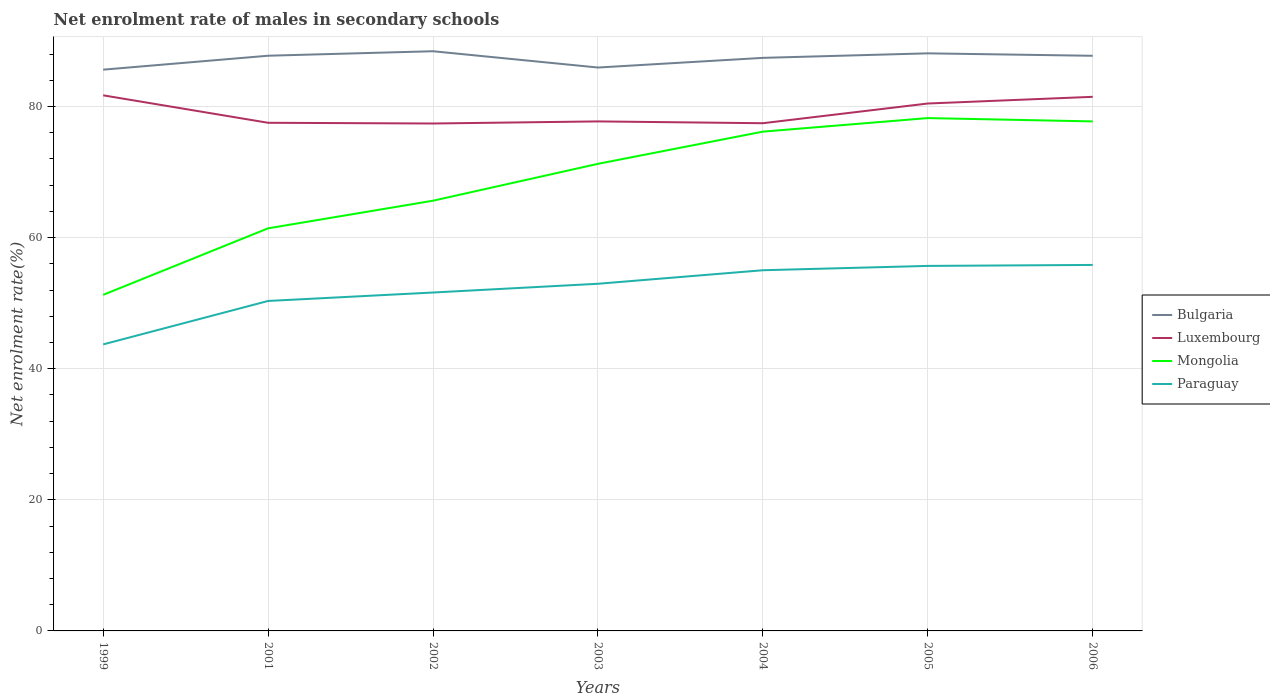Does the line corresponding to Bulgaria intersect with the line corresponding to Luxembourg?
Make the answer very short. No. Is the number of lines equal to the number of legend labels?
Give a very brief answer. Yes. Across all years, what is the maximum net enrolment rate of males in secondary schools in Bulgaria?
Provide a succinct answer. 85.63. What is the total net enrolment rate of males in secondary schools in Luxembourg in the graph?
Provide a short and direct response. -2.94. What is the difference between the highest and the second highest net enrolment rate of males in secondary schools in Luxembourg?
Your answer should be very brief. 4.3. What is the difference between the highest and the lowest net enrolment rate of males in secondary schools in Mongolia?
Your response must be concise. 4. How many lines are there?
Your answer should be very brief. 4. What is the difference between two consecutive major ticks on the Y-axis?
Provide a short and direct response. 20. Are the values on the major ticks of Y-axis written in scientific E-notation?
Ensure brevity in your answer.  No. Where does the legend appear in the graph?
Offer a very short reply. Center right. How many legend labels are there?
Offer a terse response. 4. How are the legend labels stacked?
Offer a terse response. Vertical. What is the title of the graph?
Provide a short and direct response. Net enrolment rate of males in secondary schools. What is the label or title of the X-axis?
Your response must be concise. Years. What is the label or title of the Y-axis?
Your answer should be compact. Net enrolment rate(%). What is the Net enrolment rate(%) of Bulgaria in 1999?
Keep it short and to the point. 85.63. What is the Net enrolment rate(%) of Luxembourg in 1999?
Offer a very short reply. 81.71. What is the Net enrolment rate(%) of Mongolia in 1999?
Your answer should be compact. 51.28. What is the Net enrolment rate(%) of Paraguay in 1999?
Your answer should be compact. 43.71. What is the Net enrolment rate(%) in Bulgaria in 2001?
Make the answer very short. 87.76. What is the Net enrolment rate(%) of Luxembourg in 2001?
Your answer should be compact. 77.53. What is the Net enrolment rate(%) of Mongolia in 2001?
Make the answer very short. 61.42. What is the Net enrolment rate(%) of Paraguay in 2001?
Your response must be concise. 50.34. What is the Net enrolment rate(%) in Bulgaria in 2002?
Your answer should be compact. 88.44. What is the Net enrolment rate(%) of Luxembourg in 2002?
Your response must be concise. 77.42. What is the Net enrolment rate(%) in Mongolia in 2002?
Keep it short and to the point. 65.64. What is the Net enrolment rate(%) in Paraguay in 2002?
Your answer should be very brief. 51.63. What is the Net enrolment rate(%) in Bulgaria in 2003?
Offer a very short reply. 85.95. What is the Net enrolment rate(%) of Luxembourg in 2003?
Your answer should be compact. 77.73. What is the Net enrolment rate(%) of Mongolia in 2003?
Your response must be concise. 71.26. What is the Net enrolment rate(%) in Paraguay in 2003?
Make the answer very short. 52.96. What is the Net enrolment rate(%) of Bulgaria in 2004?
Make the answer very short. 87.43. What is the Net enrolment rate(%) in Luxembourg in 2004?
Your answer should be compact. 77.46. What is the Net enrolment rate(%) of Mongolia in 2004?
Keep it short and to the point. 76.17. What is the Net enrolment rate(%) in Paraguay in 2004?
Give a very brief answer. 55.03. What is the Net enrolment rate(%) of Bulgaria in 2005?
Make the answer very short. 88.12. What is the Net enrolment rate(%) of Luxembourg in 2005?
Make the answer very short. 80.46. What is the Net enrolment rate(%) of Mongolia in 2005?
Make the answer very short. 78.24. What is the Net enrolment rate(%) of Paraguay in 2005?
Offer a terse response. 55.69. What is the Net enrolment rate(%) of Bulgaria in 2006?
Provide a succinct answer. 87.75. What is the Net enrolment rate(%) of Luxembourg in 2006?
Your response must be concise. 81.49. What is the Net enrolment rate(%) of Mongolia in 2006?
Offer a very short reply. 77.73. What is the Net enrolment rate(%) of Paraguay in 2006?
Offer a very short reply. 55.84. Across all years, what is the maximum Net enrolment rate(%) of Bulgaria?
Provide a succinct answer. 88.44. Across all years, what is the maximum Net enrolment rate(%) in Luxembourg?
Provide a succinct answer. 81.71. Across all years, what is the maximum Net enrolment rate(%) of Mongolia?
Provide a short and direct response. 78.24. Across all years, what is the maximum Net enrolment rate(%) of Paraguay?
Your answer should be very brief. 55.84. Across all years, what is the minimum Net enrolment rate(%) of Bulgaria?
Give a very brief answer. 85.63. Across all years, what is the minimum Net enrolment rate(%) of Luxembourg?
Offer a terse response. 77.42. Across all years, what is the minimum Net enrolment rate(%) in Mongolia?
Give a very brief answer. 51.28. Across all years, what is the minimum Net enrolment rate(%) in Paraguay?
Your answer should be very brief. 43.71. What is the total Net enrolment rate(%) in Bulgaria in the graph?
Your response must be concise. 611.07. What is the total Net enrolment rate(%) in Luxembourg in the graph?
Provide a succinct answer. 553.8. What is the total Net enrolment rate(%) of Mongolia in the graph?
Offer a terse response. 481.75. What is the total Net enrolment rate(%) in Paraguay in the graph?
Offer a terse response. 365.2. What is the difference between the Net enrolment rate(%) of Bulgaria in 1999 and that in 2001?
Provide a short and direct response. -2.13. What is the difference between the Net enrolment rate(%) in Luxembourg in 1999 and that in 2001?
Your response must be concise. 4.19. What is the difference between the Net enrolment rate(%) in Mongolia in 1999 and that in 2001?
Provide a succinct answer. -10.15. What is the difference between the Net enrolment rate(%) in Paraguay in 1999 and that in 2001?
Make the answer very short. -6.63. What is the difference between the Net enrolment rate(%) in Bulgaria in 1999 and that in 2002?
Keep it short and to the point. -2.81. What is the difference between the Net enrolment rate(%) in Luxembourg in 1999 and that in 2002?
Provide a succinct answer. 4.3. What is the difference between the Net enrolment rate(%) in Mongolia in 1999 and that in 2002?
Your answer should be compact. -14.36. What is the difference between the Net enrolment rate(%) in Paraguay in 1999 and that in 2002?
Provide a succinct answer. -7.92. What is the difference between the Net enrolment rate(%) of Bulgaria in 1999 and that in 2003?
Provide a short and direct response. -0.33. What is the difference between the Net enrolment rate(%) in Luxembourg in 1999 and that in 2003?
Offer a very short reply. 3.98. What is the difference between the Net enrolment rate(%) of Mongolia in 1999 and that in 2003?
Your answer should be compact. -19.99. What is the difference between the Net enrolment rate(%) in Paraguay in 1999 and that in 2003?
Ensure brevity in your answer.  -9.25. What is the difference between the Net enrolment rate(%) of Bulgaria in 1999 and that in 2004?
Offer a terse response. -1.8. What is the difference between the Net enrolment rate(%) in Luxembourg in 1999 and that in 2004?
Give a very brief answer. 4.26. What is the difference between the Net enrolment rate(%) of Mongolia in 1999 and that in 2004?
Your answer should be very brief. -24.9. What is the difference between the Net enrolment rate(%) of Paraguay in 1999 and that in 2004?
Your answer should be very brief. -11.32. What is the difference between the Net enrolment rate(%) in Bulgaria in 1999 and that in 2005?
Keep it short and to the point. -2.49. What is the difference between the Net enrolment rate(%) in Luxembourg in 1999 and that in 2005?
Provide a short and direct response. 1.25. What is the difference between the Net enrolment rate(%) in Mongolia in 1999 and that in 2005?
Your response must be concise. -26.97. What is the difference between the Net enrolment rate(%) of Paraguay in 1999 and that in 2005?
Give a very brief answer. -11.98. What is the difference between the Net enrolment rate(%) in Bulgaria in 1999 and that in 2006?
Give a very brief answer. -2.12. What is the difference between the Net enrolment rate(%) in Luxembourg in 1999 and that in 2006?
Give a very brief answer. 0.23. What is the difference between the Net enrolment rate(%) of Mongolia in 1999 and that in 2006?
Offer a terse response. -26.46. What is the difference between the Net enrolment rate(%) of Paraguay in 1999 and that in 2006?
Offer a very short reply. -12.12. What is the difference between the Net enrolment rate(%) in Bulgaria in 2001 and that in 2002?
Your answer should be compact. -0.69. What is the difference between the Net enrolment rate(%) of Luxembourg in 2001 and that in 2002?
Your response must be concise. 0.11. What is the difference between the Net enrolment rate(%) in Mongolia in 2001 and that in 2002?
Offer a terse response. -4.21. What is the difference between the Net enrolment rate(%) in Paraguay in 2001 and that in 2002?
Your answer should be very brief. -1.29. What is the difference between the Net enrolment rate(%) in Bulgaria in 2001 and that in 2003?
Your response must be concise. 1.8. What is the difference between the Net enrolment rate(%) of Luxembourg in 2001 and that in 2003?
Provide a succinct answer. -0.21. What is the difference between the Net enrolment rate(%) in Mongolia in 2001 and that in 2003?
Keep it short and to the point. -9.84. What is the difference between the Net enrolment rate(%) of Paraguay in 2001 and that in 2003?
Your answer should be compact. -2.62. What is the difference between the Net enrolment rate(%) in Bulgaria in 2001 and that in 2004?
Ensure brevity in your answer.  0.33. What is the difference between the Net enrolment rate(%) of Luxembourg in 2001 and that in 2004?
Give a very brief answer. 0.07. What is the difference between the Net enrolment rate(%) in Mongolia in 2001 and that in 2004?
Your answer should be compact. -14.75. What is the difference between the Net enrolment rate(%) in Paraguay in 2001 and that in 2004?
Give a very brief answer. -4.69. What is the difference between the Net enrolment rate(%) of Bulgaria in 2001 and that in 2005?
Provide a short and direct response. -0.36. What is the difference between the Net enrolment rate(%) of Luxembourg in 2001 and that in 2005?
Offer a terse response. -2.94. What is the difference between the Net enrolment rate(%) of Mongolia in 2001 and that in 2005?
Make the answer very short. -16.82. What is the difference between the Net enrolment rate(%) in Paraguay in 2001 and that in 2005?
Your answer should be very brief. -5.35. What is the difference between the Net enrolment rate(%) of Bulgaria in 2001 and that in 2006?
Your answer should be very brief. 0.01. What is the difference between the Net enrolment rate(%) of Luxembourg in 2001 and that in 2006?
Your response must be concise. -3.96. What is the difference between the Net enrolment rate(%) in Mongolia in 2001 and that in 2006?
Ensure brevity in your answer.  -16.31. What is the difference between the Net enrolment rate(%) in Paraguay in 2001 and that in 2006?
Provide a short and direct response. -5.49. What is the difference between the Net enrolment rate(%) in Bulgaria in 2002 and that in 2003?
Make the answer very short. 2.49. What is the difference between the Net enrolment rate(%) of Luxembourg in 2002 and that in 2003?
Keep it short and to the point. -0.32. What is the difference between the Net enrolment rate(%) in Mongolia in 2002 and that in 2003?
Your answer should be compact. -5.63. What is the difference between the Net enrolment rate(%) of Paraguay in 2002 and that in 2003?
Keep it short and to the point. -1.34. What is the difference between the Net enrolment rate(%) of Bulgaria in 2002 and that in 2004?
Make the answer very short. 1.01. What is the difference between the Net enrolment rate(%) in Luxembourg in 2002 and that in 2004?
Keep it short and to the point. -0.04. What is the difference between the Net enrolment rate(%) in Mongolia in 2002 and that in 2004?
Provide a succinct answer. -10.54. What is the difference between the Net enrolment rate(%) of Paraguay in 2002 and that in 2004?
Ensure brevity in your answer.  -3.4. What is the difference between the Net enrolment rate(%) in Bulgaria in 2002 and that in 2005?
Your answer should be very brief. 0.32. What is the difference between the Net enrolment rate(%) in Luxembourg in 2002 and that in 2005?
Offer a very short reply. -3.05. What is the difference between the Net enrolment rate(%) of Mongolia in 2002 and that in 2005?
Give a very brief answer. -12.61. What is the difference between the Net enrolment rate(%) of Paraguay in 2002 and that in 2005?
Your answer should be compact. -4.06. What is the difference between the Net enrolment rate(%) in Bulgaria in 2002 and that in 2006?
Your answer should be compact. 0.69. What is the difference between the Net enrolment rate(%) in Luxembourg in 2002 and that in 2006?
Offer a very short reply. -4.07. What is the difference between the Net enrolment rate(%) in Mongolia in 2002 and that in 2006?
Keep it short and to the point. -12.1. What is the difference between the Net enrolment rate(%) in Paraguay in 2002 and that in 2006?
Make the answer very short. -4.21. What is the difference between the Net enrolment rate(%) in Bulgaria in 2003 and that in 2004?
Provide a short and direct response. -1.47. What is the difference between the Net enrolment rate(%) in Luxembourg in 2003 and that in 2004?
Offer a very short reply. 0.28. What is the difference between the Net enrolment rate(%) in Mongolia in 2003 and that in 2004?
Ensure brevity in your answer.  -4.91. What is the difference between the Net enrolment rate(%) in Paraguay in 2003 and that in 2004?
Your answer should be compact. -2.06. What is the difference between the Net enrolment rate(%) in Bulgaria in 2003 and that in 2005?
Provide a succinct answer. -2.16. What is the difference between the Net enrolment rate(%) in Luxembourg in 2003 and that in 2005?
Provide a short and direct response. -2.73. What is the difference between the Net enrolment rate(%) of Mongolia in 2003 and that in 2005?
Give a very brief answer. -6.98. What is the difference between the Net enrolment rate(%) of Paraguay in 2003 and that in 2005?
Your response must be concise. -2.72. What is the difference between the Net enrolment rate(%) in Bulgaria in 2003 and that in 2006?
Ensure brevity in your answer.  -1.79. What is the difference between the Net enrolment rate(%) of Luxembourg in 2003 and that in 2006?
Your answer should be very brief. -3.75. What is the difference between the Net enrolment rate(%) of Mongolia in 2003 and that in 2006?
Make the answer very short. -6.47. What is the difference between the Net enrolment rate(%) of Paraguay in 2003 and that in 2006?
Ensure brevity in your answer.  -2.87. What is the difference between the Net enrolment rate(%) of Bulgaria in 2004 and that in 2005?
Make the answer very short. -0.69. What is the difference between the Net enrolment rate(%) in Luxembourg in 2004 and that in 2005?
Your answer should be very brief. -3.01. What is the difference between the Net enrolment rate(%) in Mongolia in 2004 and that in 2005?
Keep it short and to the point. -2.07. What is the difference between the Net enrolment rate(%) of Paraguay in 2004 and that in 2005?
Offer a terse response. -0.66. What is the difference between the Net enrolment rate(%) in Bulgaria in 2004 and that in 2006?
Offer a very short reply. -0.32. What is the difference between the Net enrolment rate(%) of Luxembourg in 2004 and that in 2006?
Give a very brief answer. -4.03. What is the difference between the Net enrolment rate(%) of Mongolia in 2004 and that in 2006?
Your answer should be compact. -1.56. What is the difference between the Net enrolment rate(%) of Paraguay in 2004 and that in 2006?
Ensure brevity in your answer.  -0.81. What is the difference between the Net enrolment rate(%) of Bulgaria in 2005 and that in 2006?
Keep it short and to the point. 0.37. What is the difference between the Net enrolment rate(%) of Luxembourg in 2005 and that in 2006?
Provide a succinct answer. -1.02. What is the difference between the Net enrolment rate(%) of Mongolia in 2005 and that in 2006?
Your response must be concise. 0.51. What is the difference between the Net enrolment rate(%) of Paraguay in 2005 and that in 2006?
Your answer should be very brief. -0.15. What is the difference between the Net enrolment rate(%) of Bulgaria in 1999 and the Net enrolment rate(%) of Luxembourg in 2001?
Your answer should be compact. 8.1. What is the difference between the Net enrolment rate(%) of Bulgaria in 1999 and the Net enrolment rate(%) of Mongolia in 2001?
Provide a succinct answer. 24.21. What is the difference between the Net enrolment rate(%) of Bulgaria in 1999 and the Net enrolment rate(%) of Paraguay in 2001?
Your answer should be compact. 35.29. What is the difference between the Net enrolment rate(%) in Luxembourg in 1999 and the Net enrolment rate(%) in Mongolia in 2001?
Ensure brevity in your answer.  20.29. What is the difference between the Net enrolment rate(%) of Luxembourg in 1999 and the Net enrolment rate(%) of Paraguay in 2001?
Offer a terse response. 31.37. What is the difference between the Net enrolment rate(%) in Mongolia in 1999 and the Net enrolment rate(%) in Paraguay in 2001?
Give a very brief answer. 0.93. What is the difference between the Net enrolment rate(%) of Bulgaria in 1999 and the Net enrolment rate(%) of Luxembourg in 2002?
Offer a terse response. 8.21. What is the difference between the Net enrolment rate(%) of Bulgaria in 1999 and the Net enrolment rate(%) of Mongolia in 2002?
Provide a short and direct response. 19.99. What is the difference between the Net enrolment rate(%) in Bulgaria in 1999 and the Net enrolment rate(%) in Paraguay in 2002?
Your response must be concise. 34. What is the difference between the Net enrolment rate(%) in Luxembourg in 1999 and the Net enrolment rate(%) in Mongolia in 2002?
Give a very brief answer. 16.08. What is the difference between the Net enrolment rate(%) in Luxembourg in 1999 and the Net enrolment rate(%) in Paraguay in 2002?
Make the answer very short. 30.09. What is the difference between the Net enrolment rate(%) in Mongolia in 1999 and the Net enrolment rate(%) in Paraguay in 2002?
Offer a very short reply. -0.35. What is the difference between the Net enrolment rate(%) of Bulgaria in 1999 and the Net enrolment rate(%) of Luxembourg in 2003?
Your response must be concise. 7.89. What is the difference between the Net enrolment rate(%) in Bulgaria in 1999 and the Net enrolment rate(%) in Mongolia in 2003?
Offer a terse response. 14.37. What is the difference between the Net enrolment rate(%) of Bulgaria in 1999 and the Net enrolment rate(%) of Paraguay in 2003?
Make the answer very short. 32.66. What is the difference between the Net enrolment rate(%) of Luxembourg in 1999 and the Net enrolment rate(%) of Mongolia in 2003?
Keep it short and to the point. 10.45. What is the difference between the Net enrolment rate(%) of Luxembourg in 1999 and the Net enrolment rate(%) of Paraguay in 2003?
Your answer should be very brief. 28.75. What is the difference between the Net enrolment rate(%) in Mongolia in 1999 and the Net enrolment rate(%) in Paraguay in 2003?
Give a very brief answer. -1.69. What is the difference between the Net enrolment rate(%) in Bulgaria in 1999 and the Net enrolment rate(%) in Luxembourg in 2004?
Ensure brevity in your answer.  8.17. What is the difference between the Net enrolment rate(%) of Bulgaria in 1999 and the Net enrolment rate(%) of Mongolia in 2004?
Provide a short and direct response. 9.46. What is the difference between the Net enrolment rate(%) of Bulgaria in 1999 and the Net enrolment rate(%) of Paraguay in 2004?
Your response must be concise. 30.6. What is the difference between the Net enrolment rate(%) in Luxembourg in 1999 and the Net enrolment rate(%) in Mongolia in 2004?
Your answer should be compact. 5.54. What is the difference between the Net enrolment rate(%) in Luxembourg in 1999 and the Net enrolment rate(%) in Paraguay in 2004?
Your answer should be very brief. 26.68. What is the difference between the Net enrolment rate(%) in Mongolia in 1999 and the Net enrolment rate(%) in Paraguay in 2004?
Provide a short and direct response. -3.75. What is the difference between the Net enrolment rate(%) in Bulgaria in 1999 and the Net enrolment rate(%) in Luxembourg in 2005?
Offer a very short reply. 5.17. What is the difference between the Net enrolment rate(%) in Bulgaria in 1999 and the Net enrolment rate(%) in Mongolia in 2005?
Make the answer very short. 7.39. What is the difference between the Net enrolment rate(%) in Bulgaria in 1999 and the Net enrolment rate(%) in Paraguay in 2005?
Keep it short and to the point. 29.94. What is the difference between the Net enrolment rate(%) of Luxembourg in 1999 and the Net enrolment rate(%) of Mongolia in 2005?
Provide a succinct answer. 3.47. What is the difference between the Net enrolment rate(%) of Luxembourg in 1999 and the Net enrolment rate(%) of Paraguay in 2005?
Your answer should be compact. 26.02. What is the difference between the Net enrolment rate(%) of Mongolia in 1999 and the Net enrolment rate(%) of Paraguay in 2005?
Provide a short and direct response. -4.41. What is the difference between the Net enrolment rate(%) in Bulgaria in 1999 and the Net enrolment rate(%) in Luxembourg in 2006?
Keep it short and to the point. 4.14. What is the difference between the Net enrolment rate(%) of Bulgaria in 1999 and the Net enrolment rate(%) of Mongolia in 2006?
Provide a succinct answer. 7.9. What is the difference between the Net enrolment rate(%) of Bulgaria in 1999 and the Net enrolment rate(%) of Paraguay in 2006?
Your answer should be compact. 29.79. What is the difference between the Net enrolment rate(%) in Luxembourg in 1999 and the Net enrolment rate(%) in Mongolia in 2006?
Make the answer very short. 3.98. What is the difference between the Net enrolment rate(%) in Luxembourg in 1999 and the Net enrolment rate(%) in Paraguay in 2006?
Keep it short and to the point. 25.88. What is the difference between the Net enrolment rate(%) in Mongolia in 1999 and the Net enrolment rate(%) in Paraguay in 2006?
Provide a short and direct response. -4.56. What is the difference between the Net enrolment rate(%) of Bulgaria in 2001 and the Net enrolment rate(%) of Luxembourg in 2002?
Make the answer very short. 10.34. What is the difference between the Net enrolment rate(%) of Bulgaria in 2001 and the Net enrolment rate(%) of Mongolia in 2002?
Your response must be concise. 22.12. What is the difference between the Net enrolment rate(%) in Bulgaria in 2001 and the Net enrolment rate(%) in Paraguay in 2002?
Provide a short and direct response. 36.13. What is the difference between the Net enrolment rate(%) of Luxembourg in 2001 and the Net enrolment rate(%) of Mongolia in 2002?
Provide a succinct answer. 11.89. What is the difference between the Net enrolment rate(%) of Luxembourg in 2001 and the Net enrolment rate(%) of Paraguay in 2002?
Offer a very short reply. 25.9. What is the difference between the Net enrolment rate(%) in Mongolia in 2001 and the Net enrolment rate(%) in Paraguay in 2002?
Ensure brevity in your answer.  9.79. What is the difference between the Net enrolment rate(%) of Bulgaria in 2001 and the Net enrolment rate(%) of Luxembourg in 2003?
Provide a short and direct response. 10.02. What is the difference between the Net enrolment rate(%) in Bulgaria in 2001 and the Net enrolment rate(%) in Mongolia in 2003?
Provide a succinct answer. 16.49. What is the difference between the Net enrolment rate(%) in Bulgaria in 2001 and the Net enrolment rate(%) in Paraguay in 2003?
Provide a short and direct response. 34.79. What is the difference between the Net enrolment rate(%) of Luxembourg in 2001 and the Net enrolment rate(%) of Mongolia in 2003?
Make the answer very short. 6.26. What is the difference between the Net enrolment rate(%) of Luxembourg in 2001 and the Net enrolment rate(%) of Paraguay in 2003?
Offer a terse response. 24.56. What is the difference between the Net enrolment rate(%) of Mongolia in 2001 and the Net enrolment rate(%) of Paraguay in 2003?
Provide a succinct answer. 8.46. What is the difference between the Net enrolment rate(%) in Bulgaria in 2001 and the Net enrolment rate(%) in Luxembourg in 2004?
Keep it short and to the point. 10.3. What is the difference between the Net enrolment rate(%) of Bulgaria in 2001 and the Net enrolment rate(%) of Mongolia in 2004?
Your response must be concise. 11.58. What is the difference between the Net enrolment rate(%) of Bulgaria in 2001 and the Net enrolment rate(%) of Paraguay in 2004?
Offer a very short reply. 32.73. What is the difference between the Net enrolment rate(%) in Luxembourg in 2001 and the Net enrolment rate(%) in Mongolia in 2004?
Provide a succinct answer. 1.35. What is the difference between the Net enrolment rate(%) in Luxembourg in 2001 and the Net enrolment rate(%) in Paraguay in 2004?
Provide a short and direct response. 22.5. What is the difference between the Net enrolment rate(%) in Mongolia in 2001 and the Net enrolment rate(%) in Paraguay in 2004?
Provide a short and direct response. 6.39. What is the difference between the Net enrolment rate(%) of Bulgaria in 2001 and the Net enrolment rate(%) of Luxembourg in 2005?
Keep it short and to the point. 7.29. What is the difference between the Net enrolment rate(%) of Bulgaria in 2001 and the Net enrolment rate(%) of Mongolia in 2005?
Give a very brief answer. 9.51. What is the difference between the Net enrolment rate(%) in Bulgaria in 2001 and the Net enrolment rate(%) in Paraguay in 2005?
Offer a very short reply. 32.07. What is the difference between the Net enrolment rate(%) in Luxembourg in 2001 and the Net enrolment rate(%) in Mongolia in 2005?
Offer a terse response. -0.72. What is the difference between the Net enrolment rate(%) in Luxembourg in 2001 and the Net enrolment rate(%) in Paraguay in 2005?
Offer a very short reply. 21.84. What is the difference between the Net enrolment rate(%) in Mongolia in 2001 and the Net enrolment rate(%) in Paraguay in 2005?
Your response must be concise. 5.73. What is the difference between the Net enrolment rate(%) of Bulgaria in 2001 and the Net enrolment rate(%) of Luxembourg in 2006?
Make the answer very short. 6.27. What is the difference between the Net enrolment rate(%) of Bulgaria in 2001 and the Net enrolment rate(%) of Mongolia in 2006?
Your response must be concise. 10.02. What is the difference between the Net enrolment rate(%) in Bulgaria in 2001 and the Net enrolment rate(%) in Paraguay in 2006?
Keep it short and to the point. 31.92. What is the difference between the Net enrolment rate(%) of Luxembourg in 2001 and the Net enrolment rate(%) of Mongolia in 2006?
Offer a very short reply. -0.21. What is the difference between the Net enrolment rate(%) of Luxembourg in 2001 and the Net enrolment rate(%) of Paraguay in 2006?
Ensure brevity in your answer.  21.69. What is the difference between the Net enrolment rate(%) of Mongolia in 2001 and the Net enrolment rate(%) of Paraguay in 2006?
Make the answer very short. 5.59. What is the difference between the Net enrolment rate(%) in Bulgaria in 2002 and the Net enrolment rate(%) in Luxembourg in 2003?
Offer a terse response. 10.71. What is the difference between the Net enrolment rate(%) of Bulgaria in 2002 and the Net enrolment rate(%) of Mongolia in 2003?
Make the answer very short. 17.18. What is the difference between the Net enrolment rate(%) of Bulgaria in 2002 and the Net enrolment rate(%) of Paraguay in 2003?
Offer a very short reply. 35.48. What is the difference between the Net enrolment rate(%) of Luxembourg in 2002 and the Net enrolment rate(%) of Mongolia in 2003?
Your answer should be compact. 6.15. What is the difference between the Net enrolment rate(%) of Luxembourg in 2002 and the Net enrolment rate(%) of Paraguay in 2003?
Keep it short and to the point. 24.45. What is the difference between the Net enrolment rate(%) of Mongolia in 2002 and the Net enrolment rate(%) of Paraguay in 2003?
Your answer should be very brief. 12.67. What is the difference between the Net enrolment rate(%) of Bulgaria in 2002 and the Net enrolment rate(%) of Luxembourg in 2004?
Provide a short and direct response. 10.98. What is the difference between the Net enrolment rate(%) of Bulgaria in 2002 and the Net enrolment rate(%) of Mongolia in 2004?
Provide a short and direct response. 12.27. What is the difference between the Net enrolment rate(%) in Bulgaria in 2002 and the Net enrolment rate(%) in Paraguay in 2004?
Ensure brevity in your answer.  33.41. What is the difference between the Net enrolment rate(%) in Luxembourg in 2002 and the Net enrolment rate(%) in Mongolia in 2004?
Make the answer very short. 1.24. What is the difference between the Net enrolment rate(%) of Luxembourg in 2002 and the Net enrolment rate(%) of Paraguay in 2004?
Offer a terse response. 22.39. What is the difference between the Net enrolment rate(%) of Mongolia in 2002 and the Net enrolment rate(%) of Paraguay in 2004?
Provide a short and direct response. 10.61. What is the difference between the Net enrolment rate(%) in Bulgaria in 2002 and the Net enrolment rate(%) in Luxembourg in 2005?
Ensure brevity in your answer.  7.98. What is the difference between the Net enrolment rate(%) in Bulgaria in 2002 and the Net enrolment rate(%) in Mongolia in 2005?
Make the answer very short. 10.2. What is the difference between the Net enrolment rate(%) in Bulgaria in 2002 and the Net enrolment rate(%) in Paraguay in 2005?
Ensure brevity in your answer.  32.75. What is the difference between the Net enrolment rate(%) in Luxembourg in 2002 and the Net enrolment rate(%) in Mongolia in 2005?
Make the answer very short. -0.83. What is the difference between the Net enrolment rate(%) in Luxembourg in 2002 and the Net enrolment rate(%) in Paraguay in 2005?
Provide a short and direct response. 21.73. What is the difference between the Net enrolment rate(%) of Mongolia in 2002 and the Net enrolment rate(%) of Paraguay in 2005?
Offer a terse response. 9.95. What is the difference between the Net enrolment rate(%) of Bulgaria in 2002 and the Net enrolment rate(%) of Luxembourg in 2006?
Offer a terse response. 6.95. What is the difference between the Net enrolment rate(%) of Bulgaria in 2002 and the Net enrolment rate(%) of Mongolia in 2006?
Provide a short and direct response. 10.71. What is the difference between the Net enrolment rate(%) of Bulgaria in 2002 and the Net enrolment rate(%) of Paraguay in 2006?
Your answer should be very brief. 32.6. What is the difference between the Net enrolment rate(%) of Luxembourg in 2002 and the Net enrolment rate(%) of Mongolia in 2006?
Offer a terse response. -0.32. What is the difference between the Net enrolment rate(%) in Luxembourg in 2002 and the Net enrolment rate(%) in Paraguay in 2006?
Offer a very short reply. 21.58. What is the difference between the Net enrolment rate(%) of Mongolia in 2002 and the Net enrolment rate(%) of Paraguay in 2006?
Provide a short and direct response. 9.8. What is the difference between the Net enrolment rate(%) of Bulgaria in 2003 and the Net enrolment rate(%) of Luxembourg in 2004?
Your answer should be compact. 8.5. What is the difference between the Net enrolment rate(%) in Bulgaria in 2003 and the Net enrolment rate(%) in Mongolia in 2004?
Make the answer very short. 9.78. What is the difference between the Net enrolment rate(%) in Bulgaria in 2003 and the Net enrolment rate(%) in Paraguay in 2004?
Provide a short and direct response. 30.93. What is the difference between the Net enrolment rate(%) in Luxembourg in 2003 and the Net enrolment rate(%) in Mongolia in 2004?
Your answer should be very brief. 1.56. What is the difference between the Net enrolment rate(%) in Luxembourg in 2003 and the Net enrolment rate(%) in Paraguay in 2004?
Your response must be concise. 22.71. What is the difference between the Net enrolment rate(%) of Mongolia in 2003 and the Net enrolment rate(%) of Paraguay in 2004?
Provide a succinct answer. 16.23. What is the difference between the Net enrolment rate(%) of Bulgaria in 2003 and the Net enrolment rate(%) of Luxembourg in 2005?
Provide a succinct answer. 5.49. What is the difference between the Net enrolment rate(%) of Bulgaria in 2003 and the Net enrolment rate(%) of Mongolia in 2005?
Your answer should be very brief. 7.71. What is the difference between the Net enrolment rate(%) of Bulgaria in 2003 and the Net enrolment rate(%) of Paraguay in 2005?
Make the answer very short. 30.27. What is the difference between the Net enrolment rate(%) of Luxembourg in 2003 and the Net enrolment rate(%) of Mongolia in 2005?
Offer a very short reply. -0.51. What is the difference between the Net enrolment rate(%) of Luxembourg in 2003 and the Net enrolment rate(%) of Paraguay in 2005?
Your answer should be compact. 22.05. What is the difference between the Net enrolment rate(%) of Mongolia in 2003 and the Net enrolment rate(%) of Paraguay in 2005?
Give a very brief answer. 15.57. What is the difference between the Net enrolment rate(%) in Bulgaria in 2003 and the Net enrolment rate(%) in Luxembourg in 2006?
Your answer should be compact. 4.47. What is the difference between the Net enrolment rate(%) in Bulgaria in 2003 and the Net enrolment rate(%) in Mongolia in 2006?
Your answer should be very brief. 8.22. What is the difference between the Net enrolment rate(%) in Bulgaria in 2003 and the Net enrolment rate(%) in Paraguay in 2006?
Ensure brevity in your answer.  30.12. What is the difference between the Net enrolment rate(%) in Luxembourg in 2003 and the Net enrolment rate(%) in Mongolia in 2006?
Give a very brief answer. 0. What is the difference between the Net enrolment rate(%) of Luxembourg in 2003 and the Net enrolment rate(%) of Paraguay in 2006?
Offer a very short reply. 21.9. What is the difference between the Net enrolment rate(%) in Mongolia in 2003 and the Net enrolment rate(%) in Paraguay in 2006?
Your response must be concise. 15.43. What is the difference between the Net enrolment rate(%) in Bulgaria in 2004 and the Net enrolment rate(%) in Luxembourg in 2005?
Your answer should be compact. 6.96. What is the difference between the Net enrolment rate(%) in Bulgaria in 2004 and the Net enrolment rate(%) in Mongolia in 2005?
Ensure brevity in your answer.  9.19. What is the difference between the Net enrolment rate(%) of Bulgaria in 2004 and the Net enrolment rate(%) of Paraguay in 2005?
Provide a succinct answer. 31.74. What is the difference between the Net enrolment rate(%) in Luxembourg in 2004 and the Net enrolment rate(%) in Mongolia in 2005?
Ensure brevity in your answer.  -0.78. What is the difference between the Net enrolment rate(%) in Luxembourg in 2004 and the Net enrolment rate(%) in Paraguay in 2005?
Provide a succinct answer. 21.77. What is the difference between the Net enrolment rate(%) of Mongolia in 2004 and the Net enrolment rate(%) of Paraguay in 2005?
Offer a very short reply. 20.48. What is the difference between the Net enrolment rate(%) of Bulgaria in 2004 and the Net enrolment rate(%) of Luxembourg in 2006?
Your response must be concise. 5.94. What is the difference between the Net enrolment rate(%) in Bulgaria in 2004 and the Net enrolment rate(%) in Mongolia in 2006?
Your answer should be compact. 9.69. What is the difference between the Net enrolment rate(%) in Bulgaria in 2004 and the Net enrolment rate(%) in Paraguay in 2006?
Your response must be concise. 31.59. What is the difference between the Net enrolment rate(%) of Luxembourg in 2004 and the Net enrolment rate(%) of Mongolia in 2006?
Your answer should be compact. -0.28. What is the difference between the Net enrolment rate(%) in Luxembourg in 2004 and the Net enrolment rate(%) in Paraguay in 2006?
Offer a very short reply. 21.62. What is the difference between the Net enrolment rate(%) of Mongolia in 2004 and the Net enrolment rate(%) of Paraguay in 2006?
Offer a very short reply. 20.34. What is the difference between the Net enrolment rate(%) in Bulgaria in 2005 and the Net enrolment rate(%) in Luxembourg in 2006?
Give a very brief answer. 6.63. What is the difference between the Net enrolment rate(%) in Bulgaria in 2005 and the Net enrolment rate(%) in Mongolia in 2006?
Offer a very short reply. 10.39. What is the difference between the Net enrolment rate(%) of Bulgaria in 2005 and the Net enrolment rate(%) of Paraguay in 2006?
Your answer should be very brief. 32.28. What is the difference between the Net enrolment rate(%) of Luxembourg in 2005 and the Net enrolment rate(%) of Mongolia in 2006?
Your answer should be compact. 2.73. What is the difference between the Net enrolment rate(%) of Luxembourg in 2005 and the Net enrolment rate(%) of Paraguay in 2006?
Provide a short and direct response. 24.63. What is the difference between the Net enrolment rate(%) of Mongolia in 2005 and the Net enrolment rate(%) of Paraguay in 2006?
Your response must be concise. 22.41. What is the average Net enrolment rate(%) of Bulgaria per year?
Offer a terse response. 87.3. What is the average Net enrolment rate(%) of Luxembourg per year?
Your answer should be compact. 79.11. What is the average Net enrolment rate(%) in Mongolia per year?
Provide a succinct answer. 68.82. What is the average Net enrolment rate(%) of Paraguay per year?
Provide a short and direct response. 52.17. In the year 1999, what is the difference between the Net enrolment rate(%) of Bulgaria and Net enrolment rate(%) of Luxembourg?
Offer a very short reply. 3.92. In the year 1999, what is the difference between the Net enrolment rate(%) of Bulgaria and Net enrolment rate(%) of Mongolia?
Provide a succinct answer. 34.35. In the year 1999, what is the difference between the Net enrolment rate(%) of Bulgaria and Net enrolment rate(%) of Paraguay?
Offer a very short reply. 41.92. In the year 1999, what is the difference between the Net enrolment rate(%) of Luxembourg and Net enrolment rate(%) of Mongolia?
Your answer should be very brief. 30.44. In the year 1999, what is the difference between the Net enrolment rate(%) of Luxembourg and Net enrolment rate(%) of Paraguay?
Provide a succinct answer. 38. In the year 1999, what is the difference between the Net enrolment rate(%) of Mongolia and Net enrolment rate(%) of Paraguay?
Offer a very short reply. 7.56. In the year 2001, what is the difference between the Net enrolment rate(%) of Bulgaria and Net enrolment rate(%) of Luxembourg?
Provide a succinct answer. 10.23. In the year 2001, what is the difference between the Net enrolment rate(%) in Bulgaria and Net enrolment rate(%) in Mongolia?
Provide a succinct answer. 26.33. In the year 2001, what is the difference between the Net enrolment rate(%) of Bulgaria and Net enrolment rate(%) of Paraguay?
Offer a very short reply. 37.41. In the year 2001, what is the difference between the Net enrolment rate(%) of Luxembourg and Net enrolment rate(%) of Mongolia?
Your response must be concise. 16.1. In the year 2001, what is the difference between the Net enrolment rate(%) of Luxembourg and Net enrolment rate(%) of Paraguay?
Offer a very short reply. 27.18. In the year 2001, what is the difference between the Net enrolment rate(%) of Mongolia and Net enrolment rate(%) of Paraguay?
Offer a terse response. 11.08. In the year 2002, what is the difference between the Net enrolment rate(%) of Bulgaria and Net enrolment rate(%) of Luxembourg?
Your answer should be compact. 11.02. In the year 2002, what is the difference between the Net enrolment rate(%) of Bulgaria and Net enrolment rate(%) of Mongolia?
Your response must be concise. 22.8. In the year 2002, what is the difference between the Net enrolment rate(%) in Bulgaria and Net enrolment rate(%) in Paraguay?
Keep it short and to the point. 36.81. In the year 2002, what is the difference between the Net enrolment rate(%) of Luxembourg and Net enrolment rate(%) of Mongolia?
Offer a very short reply. 11.78. In the year 2002, what is the difference between the Net enrolment rate(%) of Luxembourg and Net enrolment rate(%) of Paraguay?
Give a very brief answer. 25.79. In the year 2002, what is the difference between the Net enrolment rate(%) in Mongolia and Net enrolment rate(%) in Paraguay?
Offer a terse response. 14.01. In the year 2003, what is the difference between the Net enrolment rate(%) of Bulgaria and Net enrolment rate(%) of Luxembourg?
Make the answer very short. 8.22. In the year 2003, what is the difference between the Net enrolment rate(%) in Bulgaria and Net enrolment rate(%) in Mongolia?
Your answer should be very brief. 14.69. In the year 2003, what is the difference between the Net enrolment rate(%) in Bulgaria and Net enrolment rate(%) in Paraguay?
Keep it short and to the point. 32.99. In the year 2003, what is the difference between the Net enrolment rate(%) of Luxembourg and Net enrolment rate(%) of Mongolia?
Keep it short and to the point. 6.47. In the year 2003, what is the difference between the Net enrolment rate(%) of Luxembourg and Net enrolment rate(%) of Paraguay?
Your response must be concise. 24.77. In the year 2003, what is the difference between the Net enrolment rate(%) in Mongolia and Net enrolment rate(%) in Paraguay?
Your answer should be very brief. 18.3. In the year 2004, what is the difference between the Net enrolment rate(%) in Bulgaria and Net enrolment rate(%) in Luxembourg?
Provide a short and direct response. 9.97. In the year 2004, what is the difference between the Net enrolment rate(%) of Bulgaria and Net enrolment rate(%) of Mongolia?
Make the answer very short. 11.26. In the year 2004, what is the difference between the Net enrolment rate(%) in Bulgaria and Net enrolment rate(%) in Paraguay?
Give a very brief answer. 32.4. In the year 2004, what is the difference between the Net enrolment rate(%) in Luxembourg and Net enrolment rate(%) in Mongolia?
Provide a short and direct response. 1.29. In the year 2004, what is the difference between the Net enrolment rate(%) of Luxembourg and Net enrolment rate(%) of Paraguay?
Ensure brevity in your answer.  22.43. In the year 2004, what is the difference between the Net enrolment rate(%) of Mongolia and Net enrolment rate(%) of Paraguay?
Give a very brief answer. 21.14. In the year 2005, what is the difference between the Net enrolment rate(%) in Bulgaria and Net enrolment rate(%) in Luxembourg?
Offer a very short reply. 7.65. In the year 2005, what is the difference between the Net enrolment rate(%) of Bulgaria and Net enrolment rate(%) of Mongolia?
Make the answer very short. 9.88. In the year 2005, what is the difference between the Net enrolment rate(%) of Bulgaria and Net enrolment rate(%) of Paraguay?
Your response must be concise. 32.43. In the year 2005, what is the difference between the Net enrolment rate(%) in Luxembourg and Net enrolment rate(%) in Mongolia?
Offer a very short reply. 2.22. In the year 2005, what is the difference between the Net enrolment rate(%) in Luxembourg and Net enrolment rate(%) in Paraguay?
Your answer should be very brief. 24.78. In the year 2005, what is the difference between the Net enrolment rate(%) of Mongolia and Net enrolment rate(%) of Paraguay?
Make the answer very short. 22.55. In the year 2006, what is the difference between the Net enrolment rate(%) in Bulgaria and Net enrolment rate(%) in Luxembourg?
Your response must be concise. 6.26. In the year 2006, what is the difference between the Net enrolment rate(%) of Bulgaria and Net enrolment rate(%) of Mongolia?
Your answer should be very brief. 10.01. In the year 2006, what is the difference between the Net enrolment rate(%) in Bulgaria and Net enrolment rate(%) in Paraguay?
Ensure brevity in your answer.  31.91. In the year 2006, what is the difference between the Net enrolment rate(%) of Luxembourg and Net enrolment rate(%) of Mongolia?
Give a very brief answer. 3.75. In the year 2006, what is the difference between the Net enrolment rate(%) of Luxembourg and Net enrolment rate(%) of Paraguay?
Offer a very short reply. 25.65. In the year 2006, what is the difference between the Net enrolment rate(%) of Mongolia and Net enrolment rate(%) of Paraguay?
Your answer should be compact. 21.9. What is the ratio of the Net enrolment rate(%) of Bulgaria in 1999 to that in 2001?
Your response must be concise. 0.98. What is the ratio of the Net enrolment rate(%) of Luxembourg in 1999 to that in 2001?
Your answer should be compact. 1.05. What is the ratio of the Net enrolment rate(%) of Mongolia in 1999 to that in 2001?
Offer a very short reply. 0.83. What is the ratio of the Net enrolment rate(%) of Paraguay in 1999 to that in 2001?
Your answer should be very brief. 0.87. What is the ratio of the Net enrolment rate(%) of Bulgaria in 1999 to that in 2002?
Offer a very short reply. 0.97. What is the ratio of the Net enrolment rate(%) in Luxembourg in 1999 to that in 2002?
Make the answer very short. 1.06. What is the ratio of the Net enrolment rate(%) in Mongolia in 1999 to that in 2002?
Give a very brief answer. 0.78. What is the ratio of the Net enrolment rate(%) of Paraguay in 1999 to that in 2002?
Keep it short and to the point. 0.85. What is the ratio of the Net enrolment rate(%) of Bulgaria in 1999 to that in 2003?
Your answer should be very brief. 1. What is the ratio of the Net enrolment rate(%) in Luxembourg in 1999 to that in 2003?
Offer a very short reply. 1.05. What is the ratio of the Net enrolment rate(%) of Mongolia in 1999 to that in 2003?
Provide a succinct answer. 0.72. What is the ratio of the Net enrolment rate(%) in Paraguay in 1999 to that in 2003?
Offer a very short reply. 0.83. What is the ratio of the Net enrolment rate(%) in Bulgaria in 1999 to that in 2004?
Your answer should be compact. 0.98. What is the ratio of the Net enrolment rate(%) of Luxembourg in 1999 to that in 2004?
Make the answer very short. 1.05. What is the ratio of the Net enrolment rate(%) in Mongolia in 1999 to that in 2004?
Provide a short and direct response. 0.67. What is the ratio of the Net enrolment rate(%) of Paraguay in 1999 to that in 2004?
Provide a succinct answer. 0.79. What is the ratio of the Net enrolment rate(%) in Bulgaria in 1999 to that in 2005?
Your answer should be compact. 0.97. What is the ratio of the Net enrolment rate(%) in Luxembourg in 1999 to that in 2005?
Provide a succinct answer. 1.02. What is the ratio of the Net enrolment rate(%) in Mongolia in 1999 to that in 2005?
Provide a short and direct response. 0.66. What is the ratio of the Net enrolment rate(%) in Paraguay in 1999 to that in 2005?
Make the answer very short. 0.79. What is the ratio of the Net enrolment rate(%) in Bulgaria in 1999 to that in 2006?
Keep it short and to the point. 0.98. What is the ratio of the Net enrolment rate(%) in Mongolia in 1999 to that in 2006?
Offer a very short reply. 0.66. What is the ratio of the Net enrolment rate(%) of Paraguay in 1999 to that in 2006?
Your response must be concise. 0.78. What is the ratio of the Net enrolment rate(%) of Bulgaria in 2001 to that in 2002?
Give a very brief answer. 0.99. What is the ratio of the Net enrolment rate(%) of Luxembourg in 2001 to that in 2002?
Provide a succinct answer. 1. What is the ratio of the Net enrolment rate(%) in Mongolia in 2001 to that in 2002?
Offer a very short reply. 0.94. What is the ratio of the Net enrolment rate(%) of Paraguay in 2001 to that in 2002?
Offer a very short reply. 0.98. What is the ratio of the Net enrolment rate(%) in Bulgaria in 2001 to that in 2003?
Offer a terse response. 1.02. What is the ratio of the Net enrolment rate(%) of Mongolia in 2001 to that in 2003?
Make the answer very short. 0.86. What is the ratio of the Net enrolment rate(%) in Paraguay in 2001 to that in 2003?
Keep it short and to the point. 0.95. What is the ratio of the Net enrolment rate(%) of Bulgaria in 2001 to that in 2004?
Give a very brief answer. 1. What is the ratio of the Net enrolment rate(%) of Luxembourg in 2001 to that in 2004?
Give a very brief answer. 1. What is the ratio of the Net enrolment rate(%) in Mongolia in 2001 to that in 2004?
Provide a short and direct response. 0.81. What is the ratio of the Net enrolment rate(%) of Paraguay in 2001 to that in 2004?
Your answer should be compact. 0.91. What is the ratio of the Net enrolment rate(%) in Luxembourg in 2001 to that in 2005?
Offer a terse response. 0.96. What is the ratio of the Net enrolment rate(%) of Mongolia in 2001 to that in 2005?
Make the answer very short. 0.79. What is the ratio of the Net enrolment rate(%) of Paraguay in 2001 to that in 2005?
Offer a very short reply. 0.9. What is the ratio of the Net enrolment rate(%) in Bulgaria in 2001 to that in 2006?
Ensure brevity in your answer.  1. What is the ratio of the Net enrolment rate(%) of Luxembourg in 2001 to that in 2006?
Your answer should be very brief. 0.95. What is the ratio of the Net enrolment rate(%) in Mongolia in 2001 to that in 2006?
Ensure brevity in your answer.  0.79. What is the ratio of the Net enrolment rate(%) of Paraguay in 2001 to that in 2006?
Offer a terse response. 0.9. What is the ratio of the Net enrolment rate(%) in Bulgaria in 2002 to that in 2003?
Give a very brief answer. 1.03. What is the ratio of the Net enrolment rate(%) of Luxembourg in 2002 to that in 2003?
Ensure brevity in your answer.  1. What is the ratio of the Net enrolment rate(%) in Mongolia in 2002 to that in 2003?
Offer a terse response. 0.92. What is the ratio of the Net enrolment rate(%) of Paraguay in 2002 to that in 2003?
Your answer should be very brief. 0.97. What is the ratio of the Net enrolment rate(%) of Bulgaria in 2002 to that in 2004?
Offer a terse response. 1.01. What is the ratio of the Net enrolment rate(%) in Luxembourg in 2002 to that in 2004?
Give a very brief answer. 1. What is the ratio of the Net enrolment rate(%) of Mongolia in 2002 to that in 2004?
Keep it short and to the point. 0.86. What is the ratio of the Net enrolment rate(%) in Paraguay in 2002 to that in 2004?
Keep it short and to the point. 0.94. What is the ratio of the Net enrolment rate(%) of Bulgaria in 2002 to that in 2005?
Offer a very short reply. 1. What is the ratio of the Net enrolment rate(%) in Luxembourg in 2002 to that in 2005?
Your answer should be very brief. 0.96. What is the ratio of the Net enrolment rate(%) of Mongolia in 2002 to that in 2005?
Give a very brief answer. 0.84. What is the ratio of the Net enrolment rate(%) of Paraguay in 2002 to that in 2005?
Offer a very short reply. 0.93. What is the ratio of the Net enrolment rate(%) of Bulgaria in 2002 to that in 2006?
Offer a terse response. 1.01. What is the ratio of the Net enrolment rate(%) in Luxembourg in 2002 to that in 2006?
Provide a short and direct response. 0.95. What is the ratio of the Net enrolment rate(%) in Mongolia in 2002 to that in 2006?
Give a very brief answer. 0.84. What is the ratio of the Net enrolment rate(%) in Paraguay in 2002 to that in 2006?
Your response must be concise. 0.92. What is the ratio of the Net enrolment rate(%) in Bulgaria in 2003 to that in 2004?
Provide a short and direct response. 0.98. What is the ratio of the Net enrolment rate(%) in Luxembourg in 2003 to that in 2004?
Offer a very short reply. 1. What is the ratio of the Net enrolment rate(%) in Mongolia in 2003 to that in 2004?
Your answer should be compact. 0.94. What is the ratio of the Net enrolment rate(%) in Paraguay in 2003 to that in 2004?
Give a very brief answer. 0.96. What is the ratio of the Net enrolment rate(%) in Bulgaria in 2003 to that in 2005?
Your answer should be compact. 0.98. What is the ratio of the Net enrolment rate(%) in Luxembourg in 2003 to that in 2005?
Offer a very short reply. 0.97. What is the ratio of the Net enrolment rate(%) in Mongolia in 2003 to that in 2005?
Your answer should be very brief. 0.91. What is the ratio of the Net enrolment rate(%) of Paraguay in 2003 to that in 2005?
Your response must be concise. 0.95. What is the ratio of the Net enrolment rate(%) of Bulgaria in 2003 to that in 2006?
Make the answer very short. 0.98. What is the ratio of the Net enrolment rate(%) of Luxembourg in 2003 to that in 2006?
Your response must be concise. 0.95. What is the ratio of the Net enrolment rate(%) of Mongolia in 2003 to that in 2006?
Make the answer very short. 0.92. What is the ratio of the Net enrolment rate(%) in Paraguay in 2003 to that in 2006?
Your answer should be compact. 0.95. What is the ratio of the Net enrolment rate(%) of Bulgaria in 2004 to that in 2005?
Ensure brevity in your answer.  0.99. What is the ratio of the Net enrolment rate(%) of Luxembourg in 2004 to that in 2005?
Provide a succinct answer. 0.96. What is the ratio of the Net enrolment rate(%) of Mongolia in 2004 to that in 2005?
Your answer should be compact. 0.97. What is the ratio of the Net enrolment rate(%) in Luxembourg in 2004 to that in 2006?
Keep it short and to the point. 0.95. What is the ratio of the Net enrolment rate(%) of Mongolia in 2004 to that in 2006?
Provide a succinct answer. 0.98. What is the ratio of the Net enrolment rate(%) in Paraguay in 2004 to that in 2006?
Make the answer very short. 0.99. What is the ratio of the Net enrolment rate(%) of Bulgaria in 2005 to that in 2006?
Your response must be concise. 1. What is the ratio of the Net enrolment rate(%) in Luxembourg in 2005 to that in 2006?
Your answer should be compact. 0.99. What is the ratio of the Net enrolment rate(%) of Paraguay in 2005 to that in 2006?
Provide a short and direct response. 1. What is the difference between the highest and the second highest Net enrolment rate(%) of Bulgaria?
Your response must be concise. 0.32. What is the difference between the highest and the second highest Net enrolment rate(%) of Luxembourg?
Your answer should be compact. 0.23. What is the difference between the highest and the second highest Net enrolment rate(%) in Mongolia?
Your response must be concise. 0.51. What is the difference between the highest and the second highest Net enrolment rate(%) of Paraguay?
Provide a short and direct response. 0.15. What is the difference between the highest and the lowest Net enrolment rate(%) of Bulgaria?
Ensure brevity in your answer.  2.81. What is the difference between the highest and the lowest Net enrolment rate(%) in Luxembourg?
Ensure brevity in your answer.  4.3. What is the difference between the highest and the lowest Net enrolment rate(%) of Mongolia?
Ensure brevity in your answer.  26.97. What is the difference between the highest and the lowest Net enrolment rate(%) in Paraguay?
Offer a terse response. 12.12. 